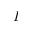Convert formula to latex. <formula><loc_0><loc_0><loc_500><loc_500>I</formula> 